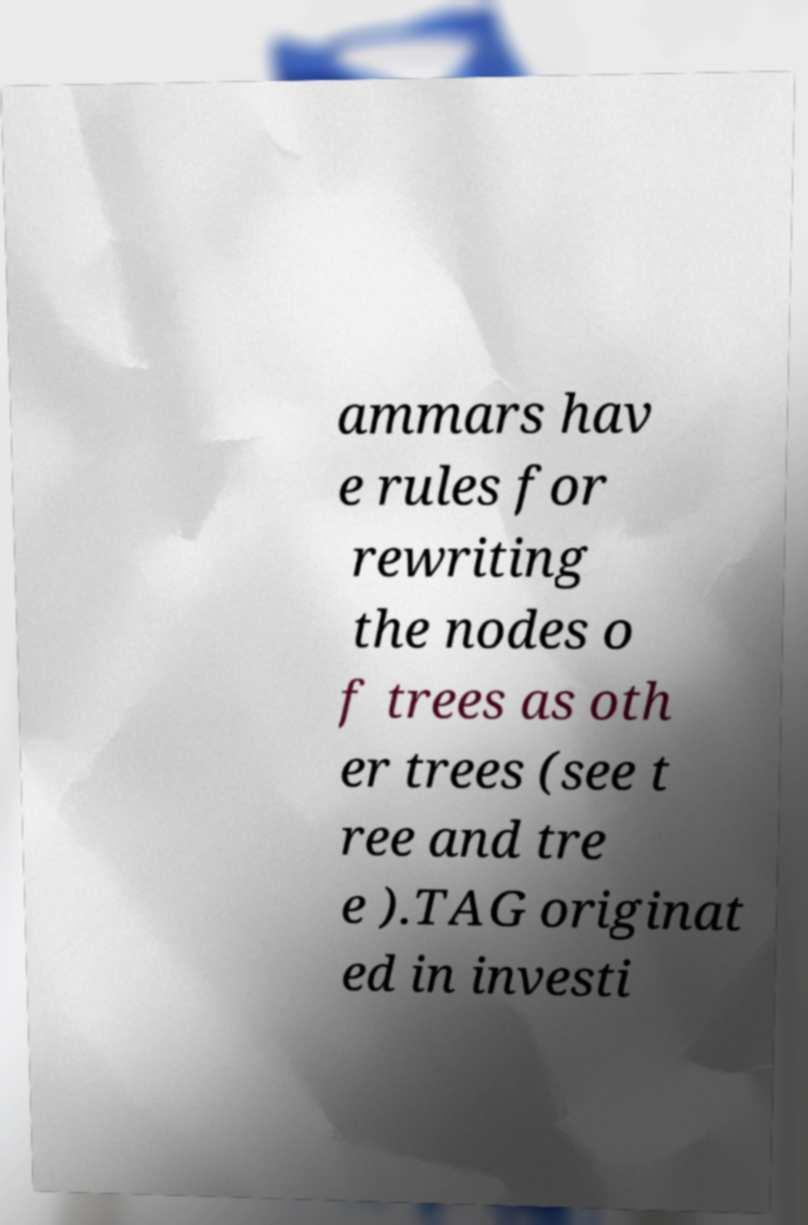I need the written content from this picture converted into text. Can you do that? ammars hav e rules for rewriting the nodes o f trees as oth er trees (see t ree and tre e ).TAG originat ed in investi 